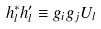Convert formula to latex. <formula><loc_0><loc_0><loc_500><loc_500>h _ { l } ^ { * } h ^ { \prime } _ { l } \equiv g _ { i } g _ { j } U _ { l }</formula> 